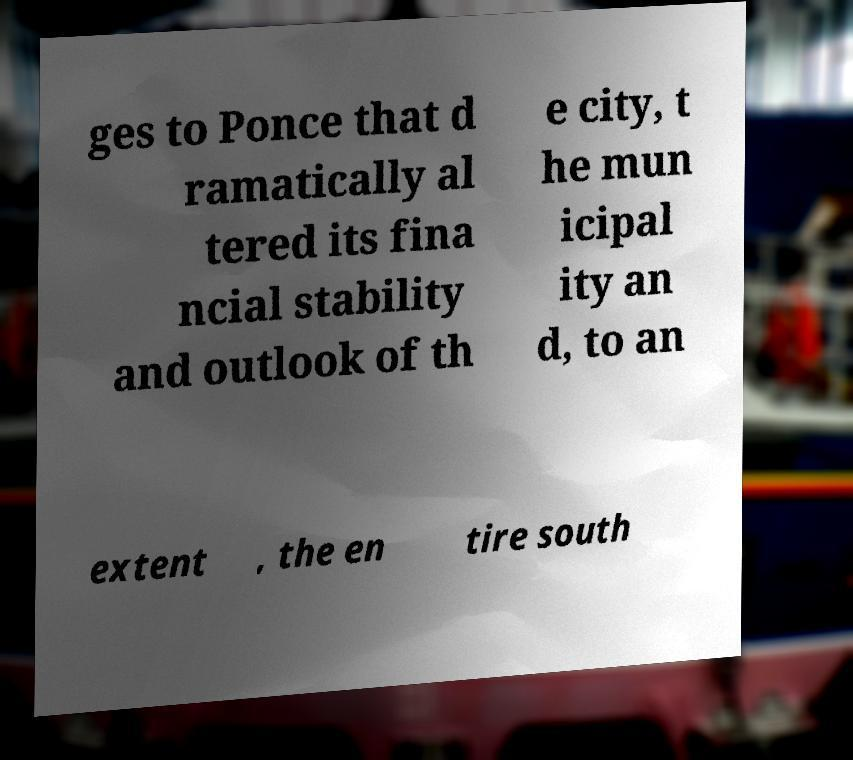What messages or text are displayed in this image? I need them in a readable, typed format. ges to Ponce that d ramatically al tered its fina ncial stability and outlook of th e city, t he mun icipal ity an d, to an extent , the en tire south 